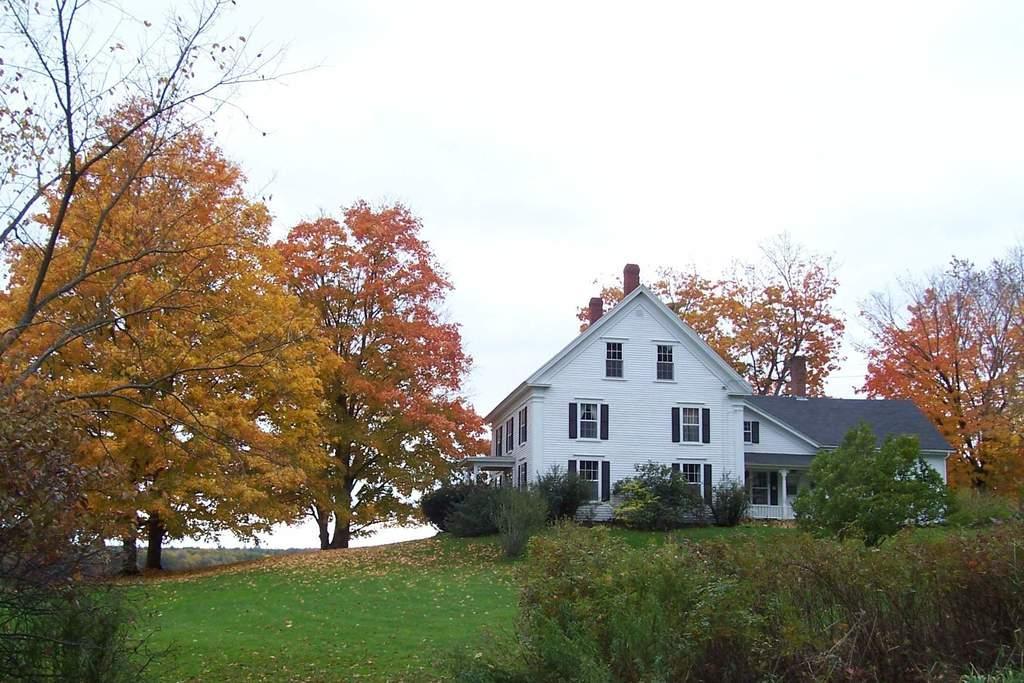Could you give a brief overview of what you see in this image? In this image there is a building beside that there is some grass, trees and plants. 